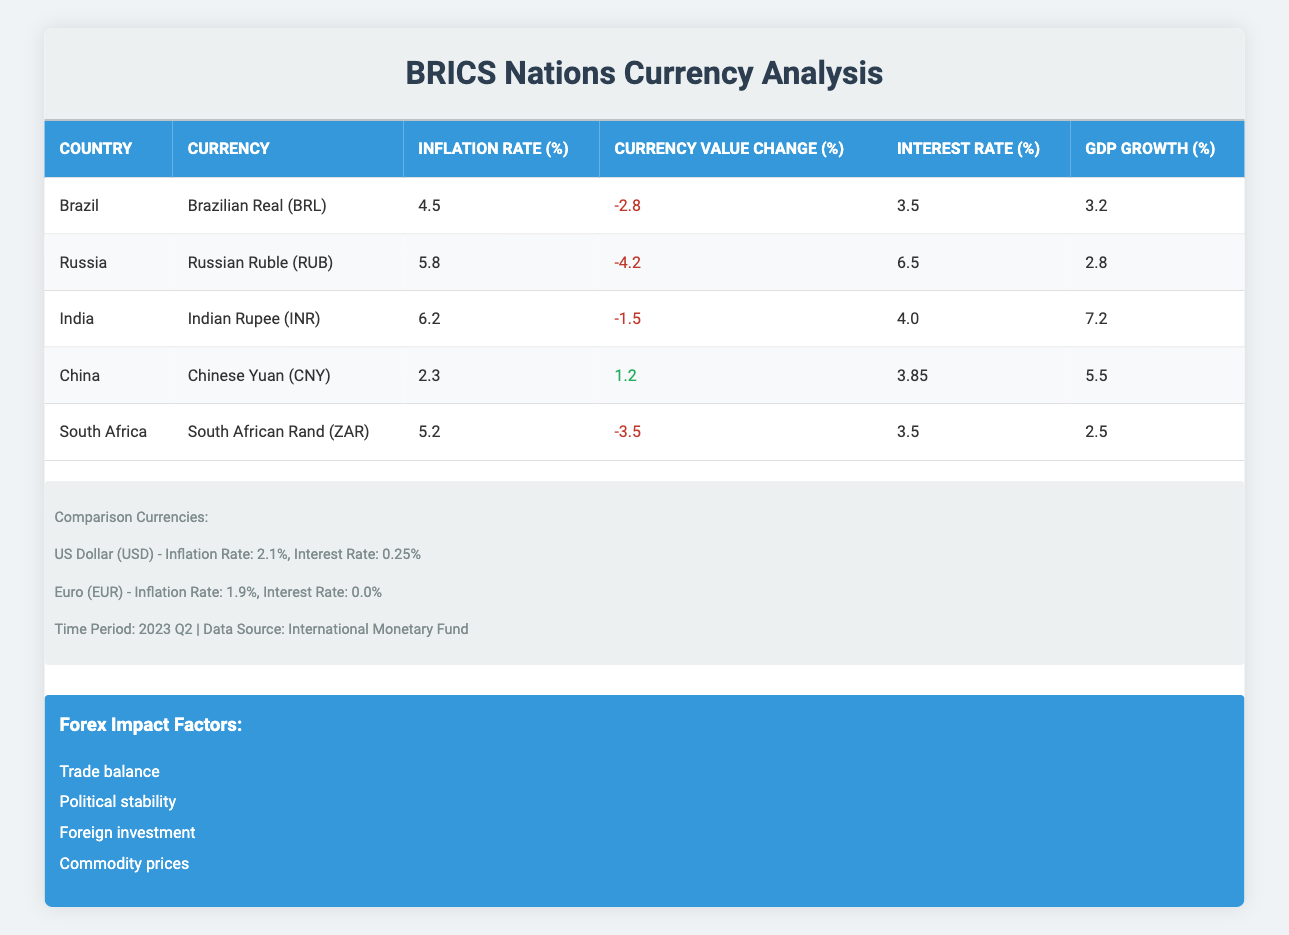What is the inflation rate for India? The table lists India with an inflation rate of 6.2%. This is directly retrieved from the inflation rate column for India.
Answer: 6.2% Which currency experienced the highest depreciation? The currency value change for each country shows that the Russian Ruble had the lowest value change at -4.2%, indicating the highest depreciation.
Answer: Russian Ruble (RUB) What is the average inflation rate of the BRICS nations? The inflation rates for the BRICS countries are (4.5 + 5.8 + 6.2 + 2.3 + 5.2) = 24.0. There are 5 countries, so the average is 24.0 / 5 = 4.8.
Answer: 4.8% Is the interest rate of China higher than that of Brazil? China has an interest rate of 3.85%, while Brazil's interest rate is 3.5%. Since 3.85% is greater than 3.5%, the statement is true.
Answer: Yes Which country has the lowest GDP growth rate among BRICS nations? Looking at the GDP growth rates, South Africa has the lowest at 2.5%. This is clearly shown in the GDP Growth column.
Answer: South Africa What is the currency value change for China? From the table, the currency value change for China is listed as 1.2%, which indicates a positive change. This is retrieved from the currency change column for China.
Answer: 1.2% Calculate the difference in inflation rates between India and China. India's inflation rate is 6.2%, and China's is 2.3%. The difference is 6.2 - 2.3 = 3.9.
Answer: 3.9 Does South Africa have a higher interest rate than the US Dollar? South Africa's interest rate is 3.5%, while the US Dollar's interest rate is 0.25%. Since 3.5% is greater than 0.25%, this statement is true.
Answer: Yes What is the relationship between inflation rate and currency value change in BRICS nations? By analyzing the data, a negative correlation can be observed where higher inflation rates (like in India and Russia) correspond to negative currency value changes. This indicates that higher inflation often negatively impacts currency value.
Answer: Negative correlation 